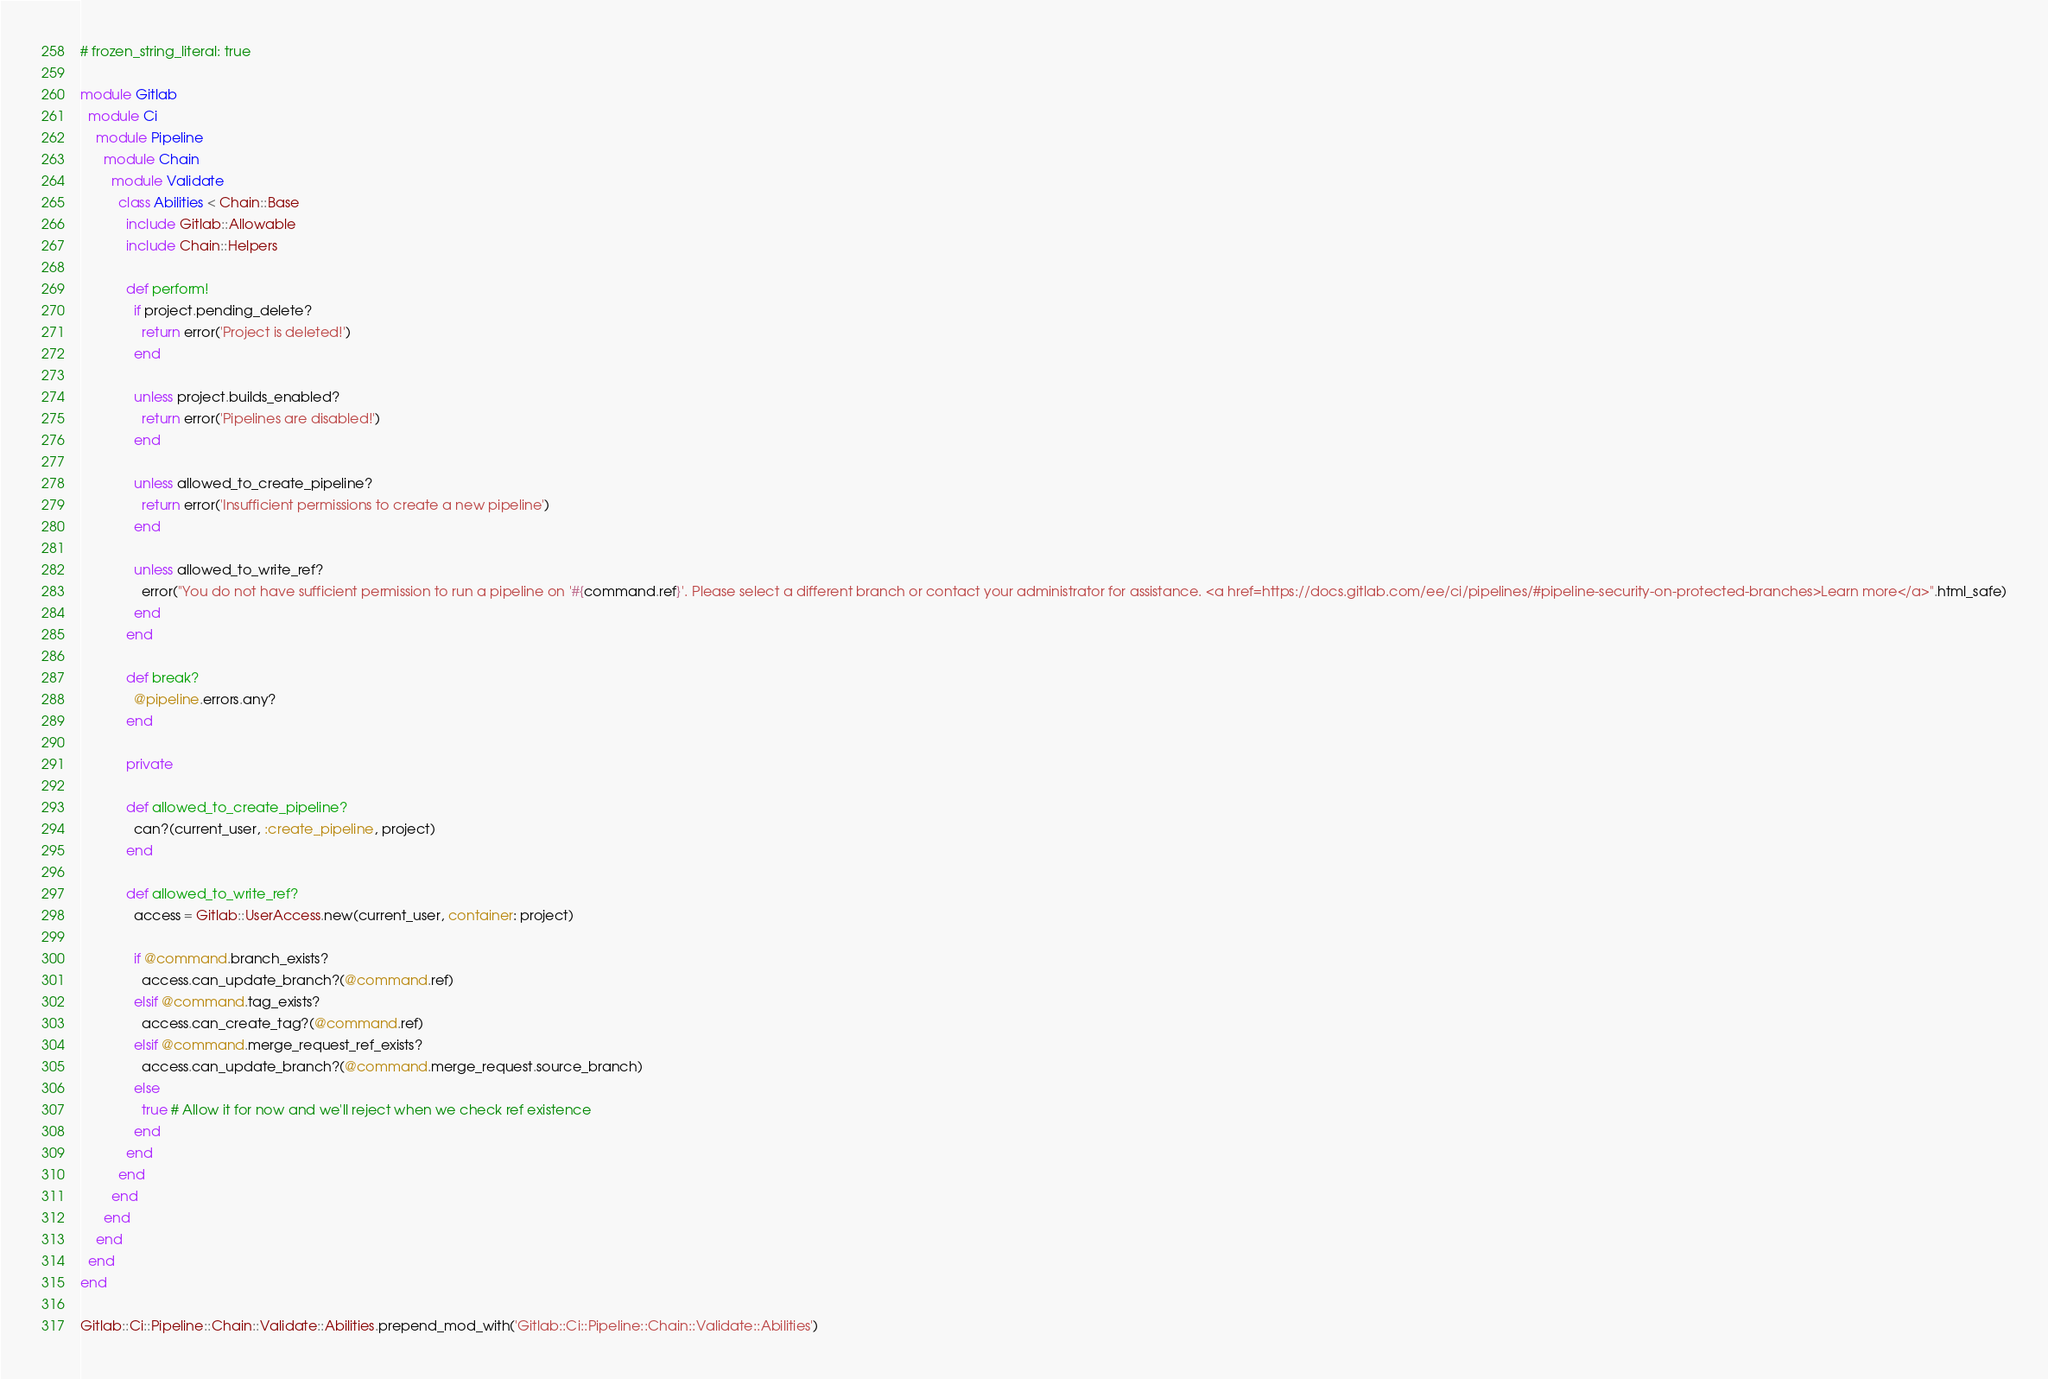<code> <loc_0><loc_0><loc_500><loc_500><_Ruby_># frozen_string_literal: true

module Gitlab
  module Ci
    module Pipeline
      module Chain
        module Validate
          class Abilities < Chain::Base
            include Gitlab::Allowable
            include Chain::Helpers

            def perform!
              if project.pending_delete?
                return error('Project is deleted!')
              end

              unless project.builds_enabled?
                return error('Pipelines are disabled!')
              end

              unless allowed_to_create_pipeline?
                return error('Insufficient permissions to create a new pipeline')
              end

              unless allowed_to_write_ref?
                error("You do not have sufficient permission to run a pipeline on '#{command.ref}'. Please select a different branch or contact your administrator for assistance. <a href=https://docs.gitlab.com/ee/ci/pipelines/#pipeline-security-on-protected-branches>Learn more</a>".html_safe)
              end
            end

            def break?
              @pipeline.errors.any?
            end

            private

            def allowed_to_create_pipeline?
              can?(current_user, :create_pipeline, project)
            end

            def allowed_to_write_ref?
              access = Gitlab::UserAccess.new(current_user, container: project)

              if @command.branch_exists?
                access.can_update_branch?(@command.ref)
              elsif @command.tag_exists?
                access.can_create_tag?(@command.ref)
              elsif @command.merge_request_ref_exists?
                access.can_update_branch?(@command.merge_request.source_branch)
              else
                true # Allow it for now and we'll reject when we check ref existence
              end
            end
          end
        end
      end
    end
  end
end

Gitlab::Ci::Pipeline::Chain::Validate::Abilities.prepend_mod_with('Gitlab::Ci::Pipeline::Chain::Validate::Abilities')
</code> 